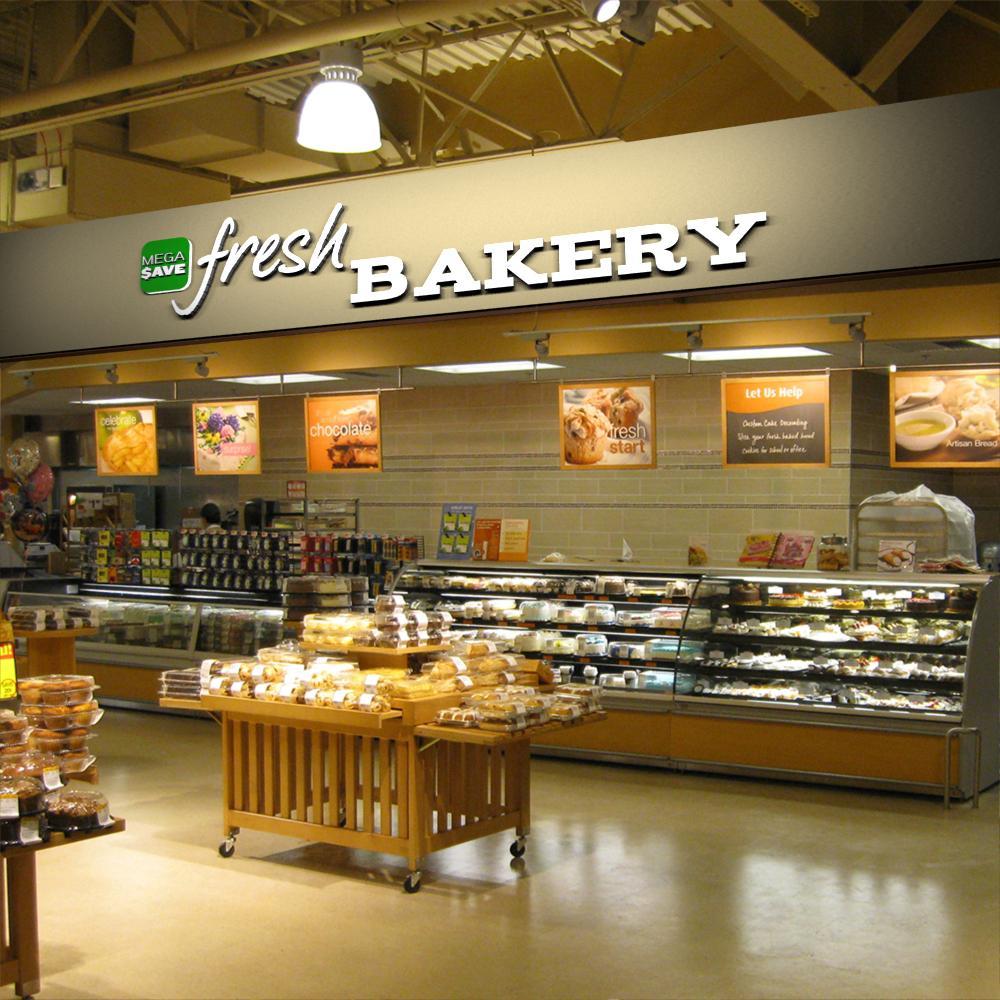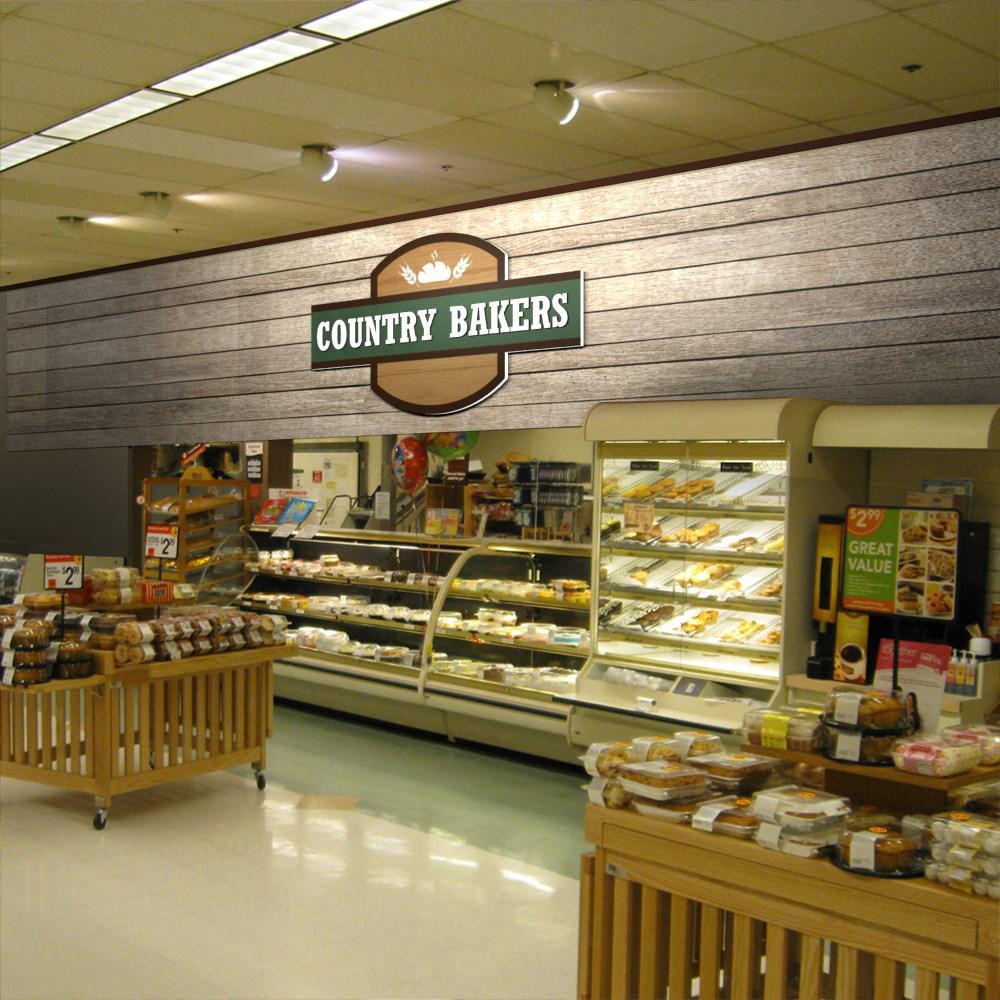The first image is the image on the left, the second image is the image on the right. Examine the images to the left and right. Is the description "The right image contains at least 2 pendant style lamps above the bakery case." accurate? Answer yes or no. No. The first image is the image on the left, the second image is the image on the right. For the images displayed, is the sentence "In at least one image you can see a dropped or lowered all white hood lamp near the bakery." factually correct? Answer yes or no. Yes. 